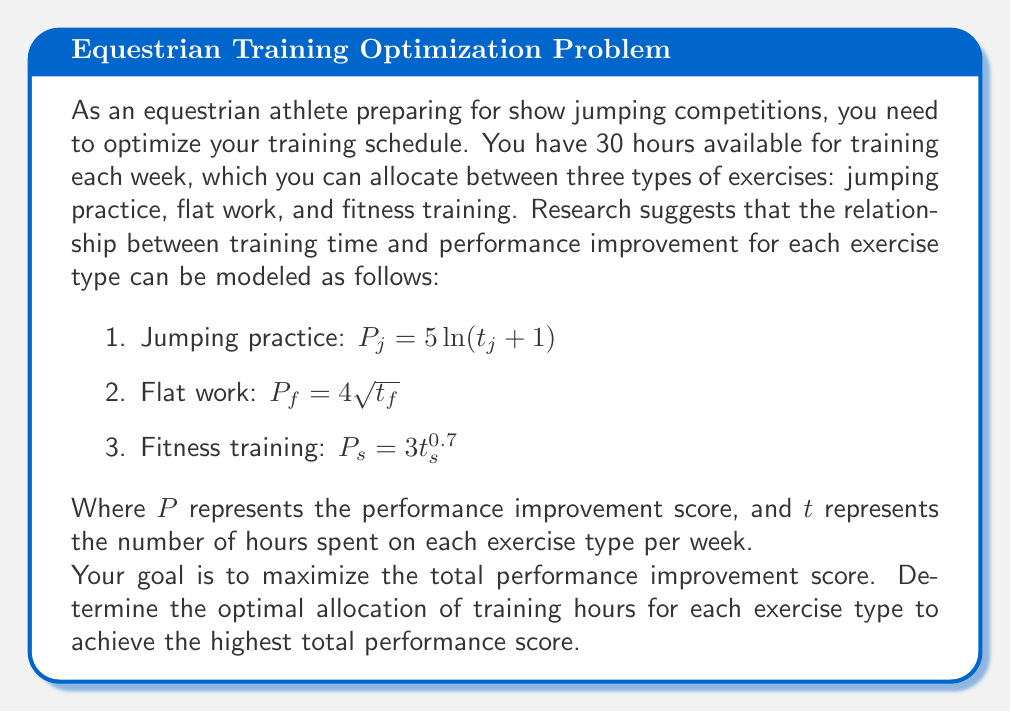Teach me how to tackle this problem. To solve this optimization problem, we need to use the method of Lagrange multipliers, as we have a constraint on the total number of hours.

Let's define our objective function as the sum of the performance improvement scores:

$$F = P_j + P_f + P_s = 5\ln(t_j + 1) + 4\sqrt{t_f} + 3t_s^{0.7}$$

Our constraint is:

$$t_j + t_f + t_s = 30$$

Now, we form the Lagrangian function:

$$L = 5\ln(t_j + 1) + 4\sqrt{t_f} + 3t_s^{0.7} - \lambda(t_j + t_f + t_s - 30)$$

To find the optimal solution, we need to take partial derivatives with respect to $t_j$, $t_f$, $t_s$, and $\lambda$, and set them equal to zero:

1) $\frac{\partial L}{\partial t_j} = \frac{5}{t_j + 1} - \lambda = 0$
2) $\frac{\partial L}{\partial t_f} = \frac{2}{\sqrt{t_f}} - \lambda = 0$
3) $\frac{\partial L}{\partial t_s} = 2.1t_s^{-0.3} - \lambda = 0$
4) $\frac{\partial L}{\partial \lambda} = t_j + t_f + t_s - 30 = 0$

From equations 1, 2, and 3, we can express $t_j$, $t_f$, and $t_s$ in terms of $\lambda$:

1) $t_j = \frac{5}{\lambda} - 1$
2) $t_f = \frac{4}{\lambda^2}$
3) $t_s = (\frac{2.1}{\lambda})^{\frac{10}{3}}$

Substituting these into equation 4:

$$(\frac{5}{\lambda} - 1) + \frac{4}{\lambda^2} + (\frac{2.1}{\lambda})^{\frac{10}{3}} = 30$$

This equation can be solved numerically to find $\lambda \approx 0.6246$.

Using this value of $\lambda$, we can calculate the optimal values for $t_j$, $t_f$, and $t_s$:

$t_j \approx 7.01$ hours
$t_f \approx 10.25$ hours
$t_s \approx 12.74$ hours

These values sum to 30 hours, satisfying our constraint.
Answer: The optimal allocation of training hours per week is:
Jumping practice: 7 hours
Flat work: 10 hours
Fitness training: 13 hours 